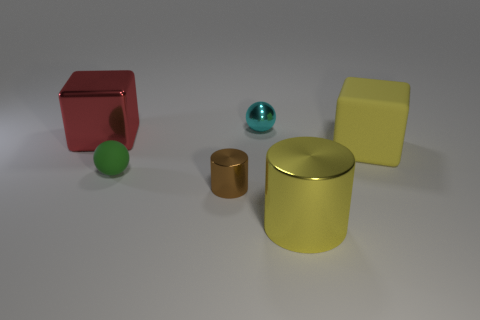Subtract 1 cylinders. How many cylinders are left? 1 Subtract all tiny purple rubber balls. Subtract all tiny green balls. How many objects are left? 5 Add 5 large blocks. How many large blocks are left? 7 Add 5 tiny yellow metallic things. How many tiny yellow metallic things exist? 5 Add 3 big purple metallic cylinders. How many objects exist? 9 Subtract 0 gray balls. How many objects are left? 6 Subtract all yellow spheres. Subtract all cyan cylinders. How many spheres are left? 2 Subtract all yellow cubes. How many yellow cylinders are left? 1 